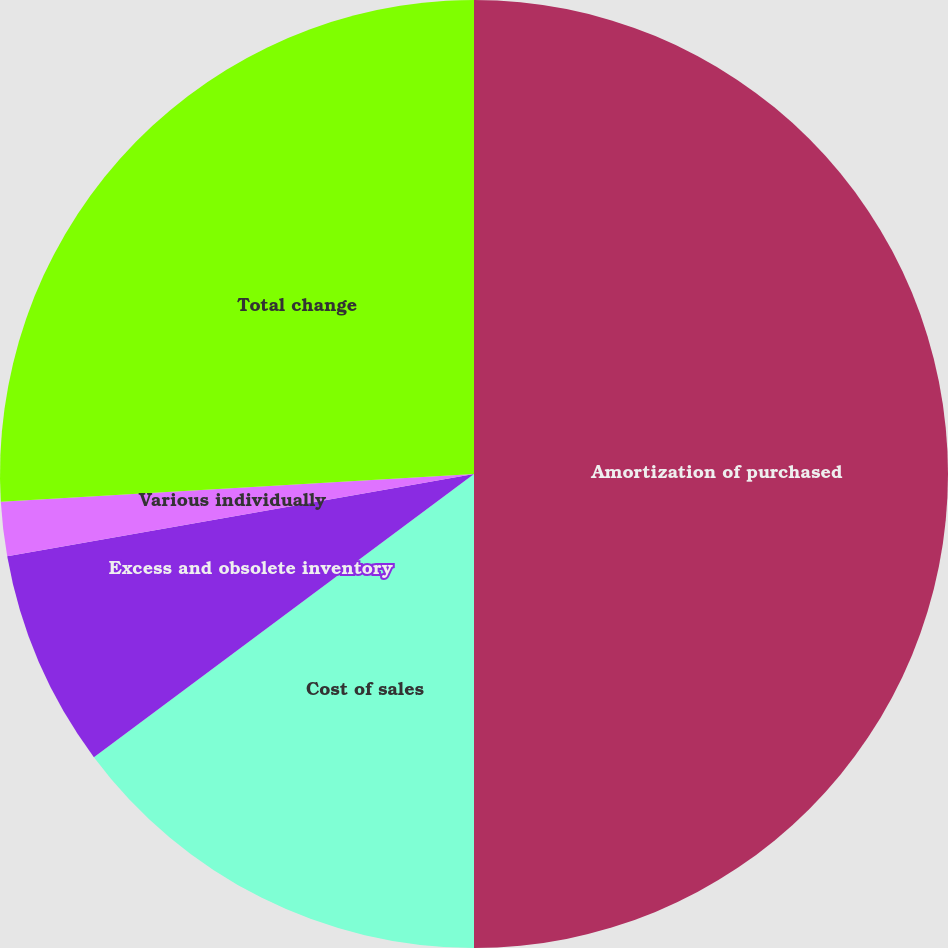Convert chart. <chart><loc_0><loc_0><loc_500><loc_500><pie_chart><fcel>Amortization of purchased<fcel>Cost of sales<fcel>Excess and obsolete inventory<fcel>Various individually<fcel>Total change<nl><fcel>50.0%<fcel>14.81%<fcel>7.41%<fcel>1.85%<fcel>25.93%<nl></chart> 